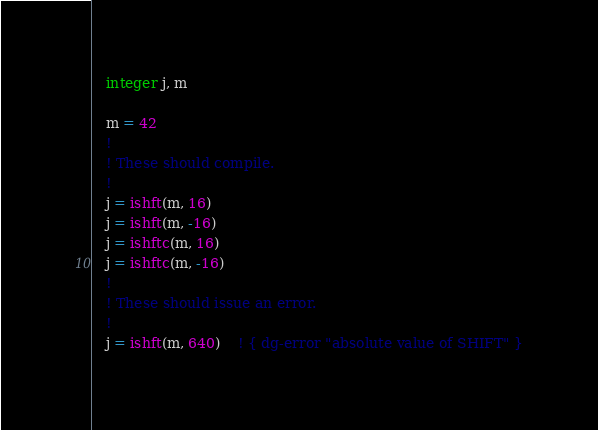Convert code to text. <code><loc_0><loc_0><loc_500><loc_500><_FORTRAN_>
   integer j, m

   m = 42
   !
   ! These should compile.
   !
   j = ishft(m, 16)
   j = ishft(m, -16)
   j = ishftc(m, 16)
   j = ishftc(m, -16)
   !
   ! These should issue an error.
   !
   j = ishft(m, 640)    ! { dg-error "absolute value of SHIFT" }</code> 